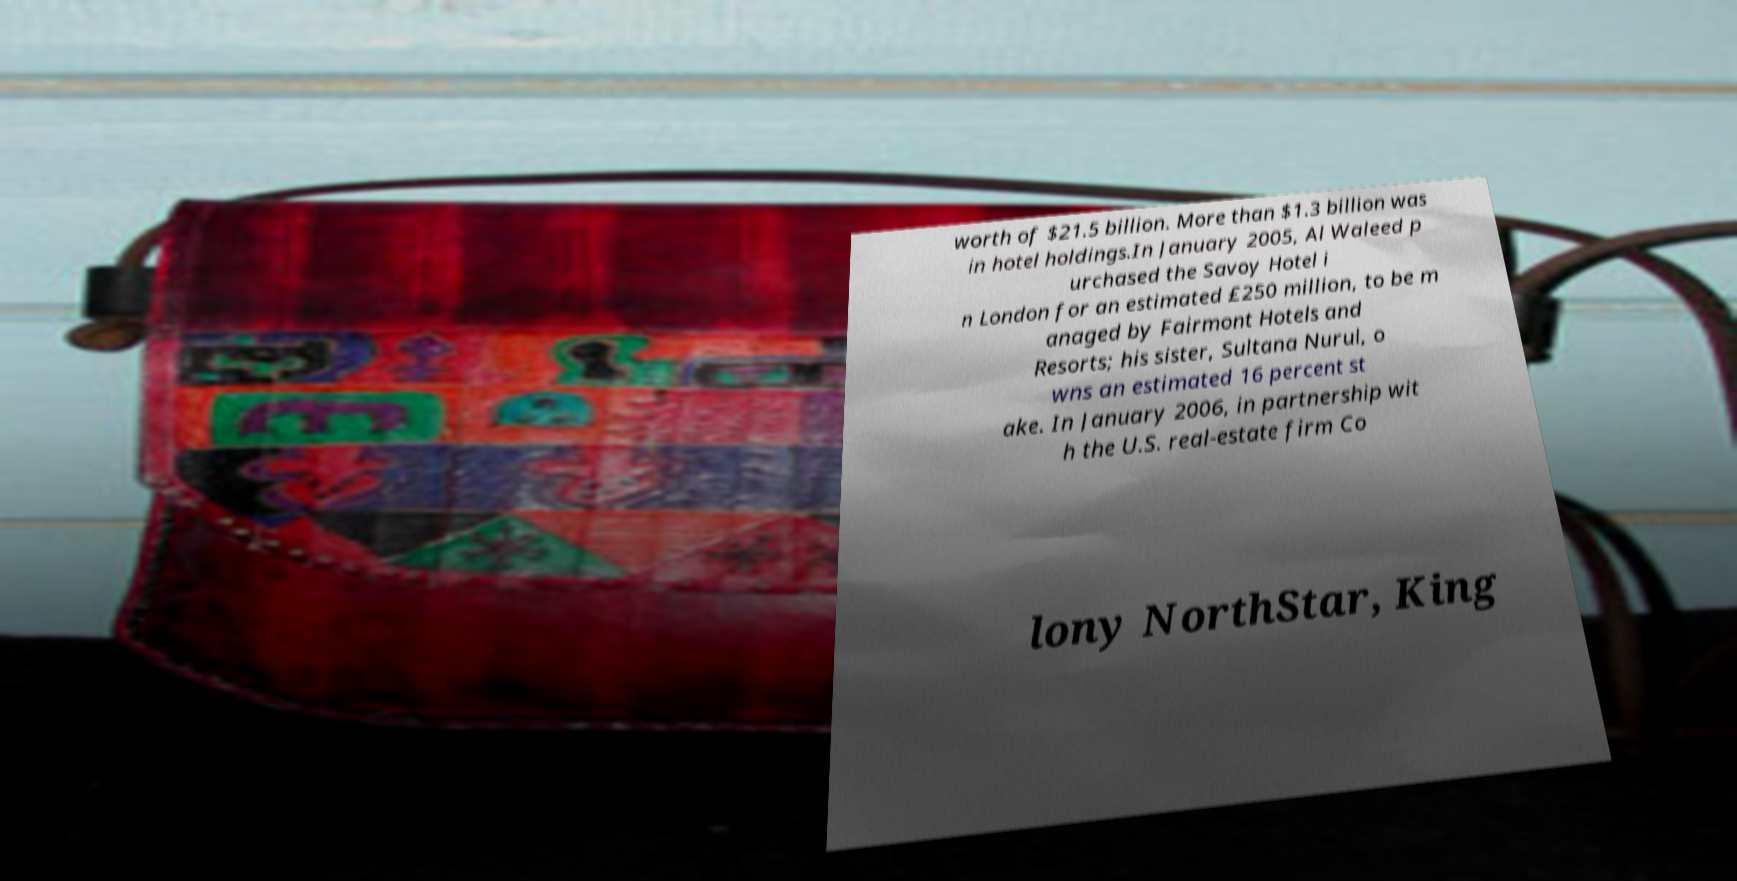Could you extract and type out the text from this image? worth of $21.5 billion. More than $1.3 billion was in hotel holdings.In January 2005, Al Waleed p urchased the Savoy Hotel i n London for an estimated £250 million, to be m anaged by Fairmont Hotels and Resorts; his sister, Sultana Nurul, o wns an estimated 16 percent st ake. In January 2006, in partnership wit h the U.S. real-estate firm Co lony NorthStar, King 